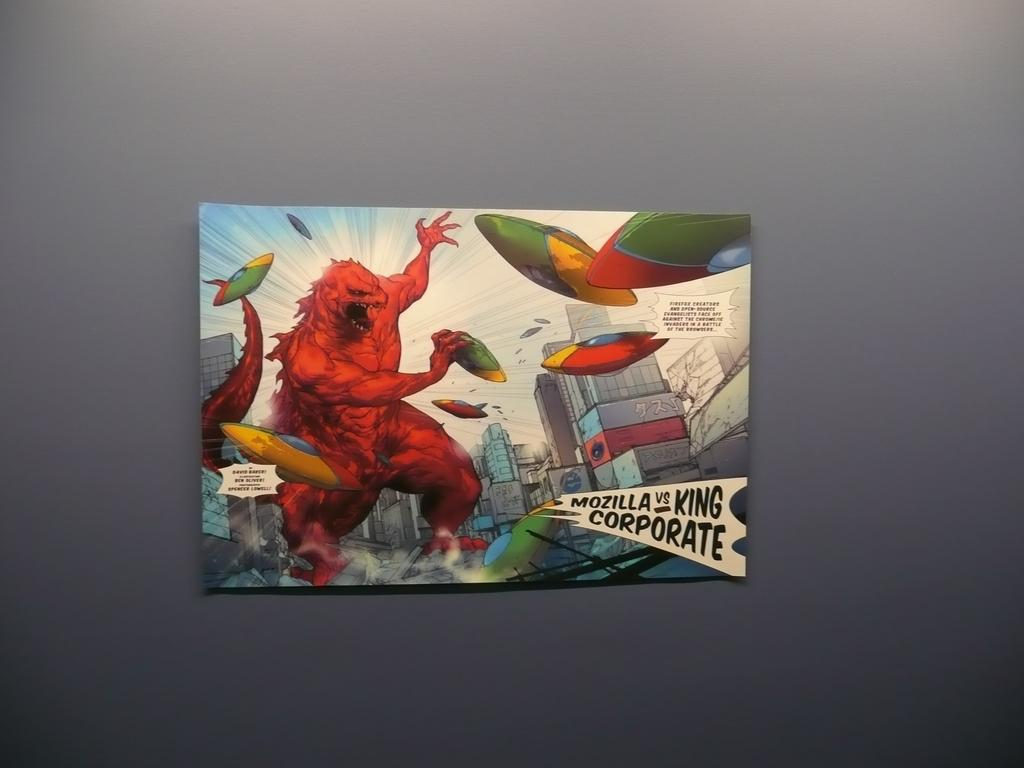<image>
Write a terse but informative summary of the picture. A comic book drawing portrays Mozilla vs. King Corporate. 